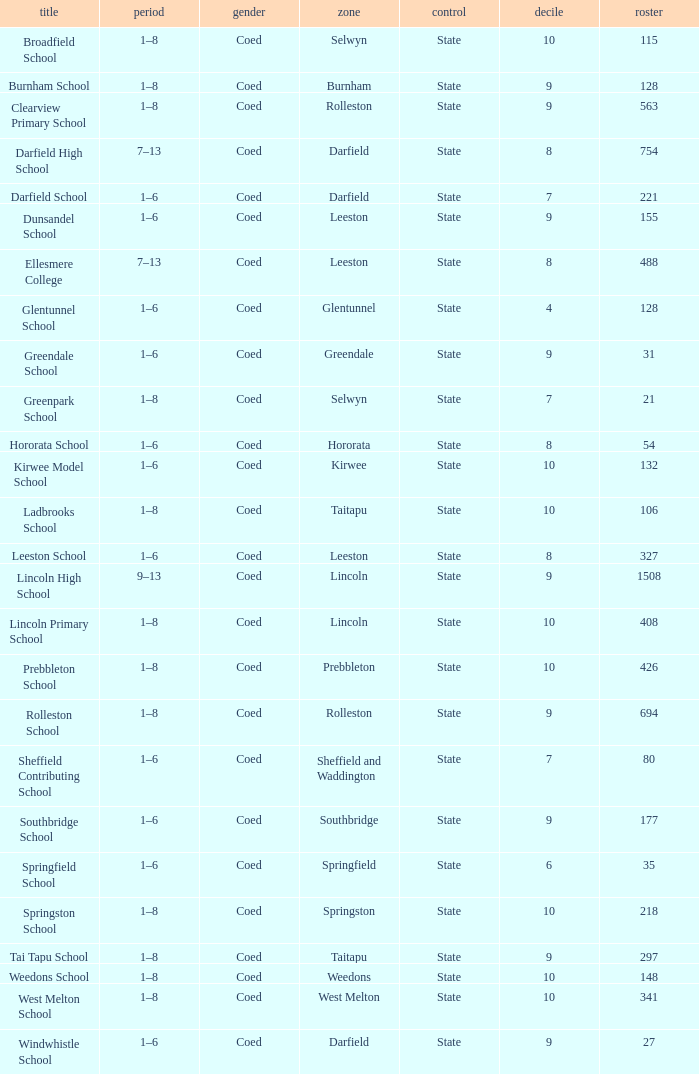What is the total of the roll with a Decile of 8, and an Area of hororata? 54.0. Give me the full table as a dictionary. {'header': ['title', 'period', 'gender', 'zone', 'control', 'decile', 'roster'], 'rows': [['Broadfield School', '1–8', 'Coed', 'Selwyn', 'State', '10', '115'], ['Burnham School', '1–8', 'Coed', 'Burnham', 'State', '9', '128'], ['Clearview Primary School', '1–8', 'Coed', 'Rolleston', 'State', '9', '563'], ['Darfield High School', '7–13', 'Coed', 'Darfield', 'State', '8', '754'], ['Darfield School', '1–6', 'Coed', 'Darfield', 'State', '7', '221'], ['Dunsandel School', '1–6', 'Coed', 'Leeston', 'State', '9', '155'], ['Ellesmere College', '7–13', 'Coed', 'Leeston', 'State', '8', '488'], ['Glentunnel School', '1–6', 'Coed', 'Glentunnel', 'State', '4', '128'], ['Greendale School', '1–6', 'Coed', 'Greendale', 'State', '9', '31'], ['Greenpark School', '1–8', 'Coed', 'Selwyn', 'State', '7', '21'], ['Hororata School', '1–6', 'Coed', 'Hororata', 'State', '8', '54'], ['Kirwee Model School', '1–6', 'Coed', 'Kirwee', 'State', '10', '132'], ['Ladbrooks School', '1–8', 'Coed', 'Taitapu', 'State', '10', '106'], ['Leeston School', '1–6', 'Coed', 'Leeston', 'State', '8', '327'], ['Lincoln High School', '9–13', 'Coed', 'Lincoln', 'State', '9', '1508'], ['Lincoln Primary School', '1–8', 'Coed', 'Lincoln', 'State', '10', '408'], ['Prebbleton School', '1–8', 'Coed', 'Prebbleton', 'State', '10', '426'], ['Rolleston School', '1–8', 'Coed', 'Rolleston', 'State', '9', '694'], ['Sheffield Contributing School', '1–6', 'Coed', 'Sheffield and Waddington', 'State', '7', '80'], ['Southbridge School', '1–6', 'Coed', 'Southbridge', 'State', '9', '177'], ['Springfield School', '1–6', 'Coed', 'Springfield', 'State', '6', '35'], ['Springston School', '1–8', 'Coed', 'Springston', 'State', '10', '218'], ['Tai Tapu School', '1–8', 'Coed', 'Taitapu', 'State', '9', '297'], ['Weedons School', '1–8', 'Coed', 'Weedons', 'State', '10', '148'], ['West Melton School', '1–8', 'Coed', 'West Melton', 'State', '10', '341'], ['Windwhistle School', '1–6', 'Coed', 'Darfield', 'State', '9', '27']]} 